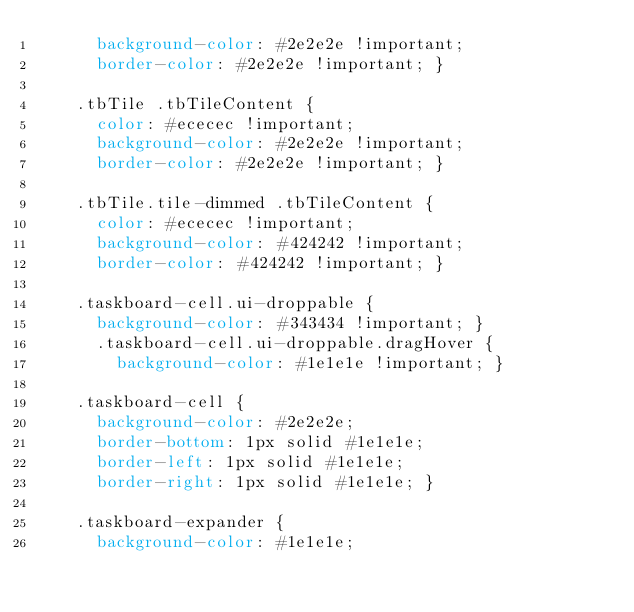<code> <loc_0><loc_0><loc_500><loc_500><_CSS_>      background-color: #2e2e2e !important;
      border-color: #2e2e2e !important; }
    
    .tbTile .tbTileContent {
      color: #ececec !important;
      background-color: #2e2e2e !important;
      border-color: #2e2e2e !important; }
    
    .tbTile.tile-dimmed .tbTileContent {
      color: #ececec !important;
      background-color: #424242 !important;
      border-color: #424242 !important; }
    
    .taskboard-cell.ui-droppable {
      background-color: #343434 !important; }
      .taskboard-cell.ui-droppable.dragHover {
        background-color: #1e1e1e !important; }
    
    .taskboard-cell {
      background-color: #2e2e2e;
      border-bottom: 1px solid #1e1e1e;
      border-left: 1px solid #1e1e1e;
      border-right: 1px solid #1e1e1e; }
    
    .taskboard-expander {
      background-color: #1e1e1e;</code> 